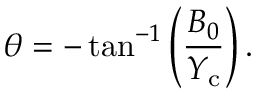Convert formula to latex. <formula><loc_0><loc_0><loc_500><loc_500>\theta = - \tan ^ { - 1 } \left ( \frac { B _ { 0 } } { Y _ { c } } \right ) .</formula> 